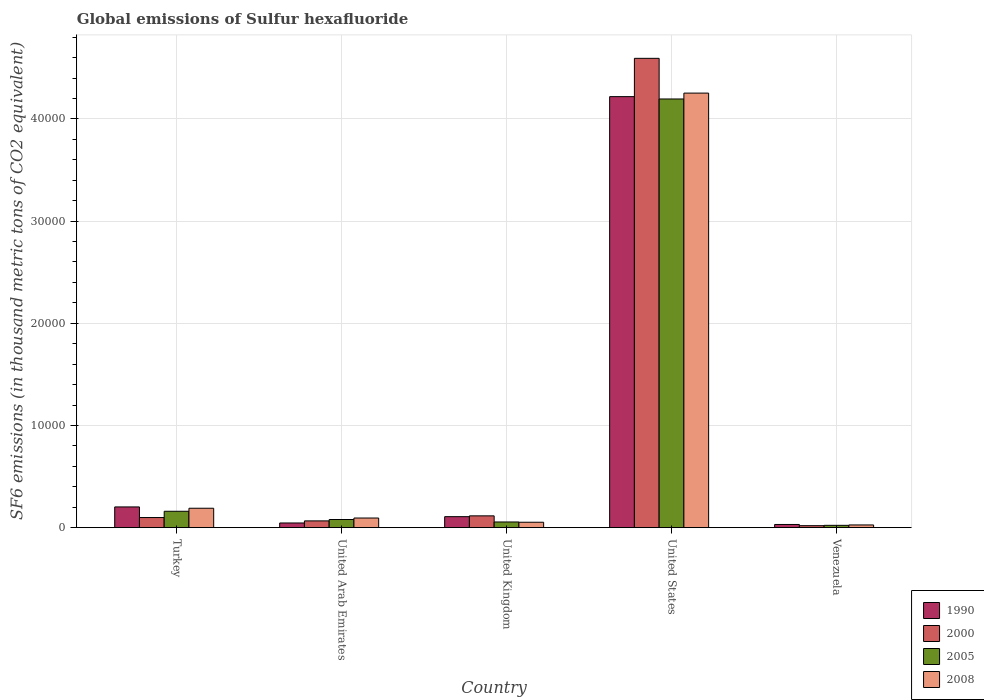How many groups of bars are there?
Provide a succinct answer. 5. Are the number of bars per tick equal to the number of legend labels?
Ensure brevity in your answer.  Yes. Are the number of bars on each tick of the X-axis equal?
Offer a terse response. Yes. How many bars are there on the 2nd tick from the left?
Your answer should be very brief. 4. How many bars are there on the 3rd tick from the right?
Give a very brief answer. 4. In how many cases, is the number of bars for a given country not equal to the number of legend labels?
Your answer should be compact. 0. What is the global emissions of Sulfur hexafluoride in 2000 in Turkey?
Ensure brevity in your answer.  989.2. Across all countries, what is the maximum global emissions of Sulfur hexafluoride in 1990?
Keep it short and to the point. 4.22e+04. Across all countries, what is the minimum global emissions of Sulfur hexafluoride in 1990?
Keep it short and to the point. 309.8. In which country was the global emissions of Sulfur hexafluoride in 2000 minimum?
Your answer should be very brief. Venezuela. What is the total global emissions of Sulfur hexafluoride in 2008 in the graph?
Ensure brevity in your answer.  4.62e+04. What is the difference between the global emissions of Sulfur hexafluoride in 2008 in United Kingdom and that in Venezuela?
Make the answer very short. 265.5. What is the difference between the global emissions of Sulfur hexafluoride in 1990 in United States and the global emissions of Sulfur hexafluoride in 2008 in Venezuela?
Offer a terse response. 4.19e+04. What is the average global emissions of Sulfur hexafluoride in 2005 per country?
Ensure brevity in your answer.  9026.12. What is the difference between the global emissions of Sulfur hexafluoride of/in 2005 and global emissions of Sulfur hexafluoride of/in 2000 in Turkey?
Provide a short and direct response. 613. What is the ratio of the global emissions of Sulfur hexafluoride in 1990 in Turkey to that in United Arab Emirates?
Keep it short and to the point. 4.44. Is the global emissions of Sulfur hexafluoride in 2005 in Turkey less than that in United Kingdom?
Offer a terse response. No. Is the difference between the global emissions of Sulfur hexafluoride in 2005 in Turkey and United Kingdom greater than the difference between the global emissions of Sulfur hexafluoride in 2000 in Turkey and United Kingdom?
Make the answer very short. Yes. What is the difference between the highest and the second highest global emissions of Sulfur hexafluoride in 1990?
Offer a very short reply. -953.2. What is the difference between the highest and the lowest global emissions of Sulfur hexafluoride in 2005?
Give a very brief answer. 4.17e+04. In how many countries, is the global emissions of Sulfur hexafluoride in 2005 greater than the average global emissions of Sulfur hexafluoride in 2005 taken over all countries?
Your answer should be very brief. 1. Is the sum of the global emissions of Sulfur hexafluoride in 2000 in United Arab Emirates and United Kingdom greater than the maximum global emissions of Sulfur hexafluoride in 2008 across all countries?
Your response must be concise. No. Is it the case that in every country, the sum of the global emissions of Sulfur hexafluoride in 1990 and global emissions of Sulfur hexafluoride in 2000 is greater than the sum of global emissions of Sulfur hexafluoride in 2005 and global emissions of Sulfur hexafluoride in 2008?
Offer a very short reply. No. What does the 4th bar from the left in Turkey represents?
Make the answer very short. 2008. What does the 2nd bar from the right in Turkey represents?
Make the answer very short. 2005. How many bars are there?
Give a very brief answer. 20. How many countries are there in the graph?
Your answer should be very brief. 5. Does the graph contain any zero values?
Make the answer very short. No. Does the graph contain grids?
Your answer should be compact. Yes. Where does the legend appear in the graph?
Make the answer very short. Bottom right. What is the title of the graph?
Your answer should be compact. Global emissions of Sulfur hexafluoride. What is the label or title of the Y-axis?
Offer a terse response. SF6 emissions (in thousand metric tons of CO2 equivalent). What is the SF6 emissions (in thousand metric tons of CO2 equivalent) of 1990 in Turkey?
Offer a very short reply. 2027.1. What is the SF6 emissions (in thousand metric tons of CO2 equivalent) in 2000 in Turkey?
Your answer should be compact. 989.2. What is the SF6 emissions (in thousand metric tons of CO2 equivalent) of 2005 in Turkey?
Offer a terse response. 1602.2. What is the SF6 emissions (in thousand metric tons of CO2 equivalent) in 2008 in Turkey?
Your answer should be very brief. 1898.8. What is the SF6 emissions (in thousand metric tons of CO2 equivalent) of 1990 in United Arab Emirates?
Provide a short and direct response. 456.1. What is the SF6 emissions (in thousand metric tons of CO2 equivalent) in 2000 in United Arab Emirates?
Make the answer very short. 660.1. What is the SF6 emissions (in thousand metric tons of CO2 equivalent) in 2005 in United Arab Emirates?
Ensure brevity in your answer.  796.2. What is the SF6 emissions (in thousand metric tons of CO2 equivalent) of 2008 in United Arab Emirates?
Make the answer very short. 941.4. What is the SF6 emissions (in thousand metric tons of CO2 equivalent) in 1990 in United Kingdom?
Your response must be concise. 1073.9. What is the SF6 emissions (in thousand metric tons of CO2 equivalent) of 2000 in United Kingdom?
Give a very brief answer. 1154.1. What is the SF6 emissions (in thousand metric tons of CO2 equivalent) in 2005 in United Kingdom?
Provide a succinct answer. 554.2. What is the SF6 emissions (in thousand metric tons of CO2 equivalent) of 2008 in United Kingdom?
Provide a short and direct response. 528.9. What is the SF6 emissions (in thousand metric tons of CO2 equivalent) in 1990 in United States?
Your answer should be very brief. 4.22e+04. What is the SF6 emissions (in thousand metric tons of CO2 equivalent) in 2000 in United States?
Offer a very short reply. 4.59e+04. What is the SF6 emissions (in thousand metric tons of CO2 equivalent) in 2005 in United States?
Your answer should be very brief. 4.20e+04. What is the SF6 emissions (in thousand metric tons of CO2 equivalent) of 2008 in United States?
Provide a succinct answer. 4.25e+04. What is the SF6 emissions (in thousand metric tons of CO2 equivalent) in 1990 in Venezuela?
Offer a terse response. 309.8. What is the SF6 emissions (in thousand metric tons of CO2 equivalent) of 2000 in Venezuela?
Offer a very short reply. 191.4. What is the SF6 emissions (in thousand metric tons of CO2 equivalent) of 2005 in Venezuela?
Give a very brief answer. 225.1. What is the SF6 emissions (in thousand metric tons of CO2 equivalent) in 2008 in Venezuela?
Provide a succinct answer. 263.4. Across all countries, what is the maximum SF6 emissions (in thousand metric tons of CO2 equivalent) of 1990?
Your response must be concise. 4.22e+04. Across all countries, what is the maximum SF6 emissions (in thousand metric tons of CO2 equivalent) of 2000?
Your answer should be very brief. 4.59e+04. Across all countries, what is the maximum SF6 emissions (in thousand metric tons of CO2 equivalent) of 2005?
Give a very brief answer. 4.20e+04. Across all countries, what is the maximum SF6 emissions (in thousand metric tons of CO2 equivalent) of 2008?
Provide a succinct answer. 4.25e+04. Across all countries, what is the minimum SF6 emissions (in thousand metric tons of CO2 equivalent) in 1990?
Offer a terse response. 309.8. Across all countries, what is the minimum SF6 emissions (in thousand metric tons of CO2 equivalent) in 2000?
Give a very brief answer. 191.4. Across all countries, what is the minimum SF6 emissions (in thousand metric tons of CO2 equivalent) of 2005?
Keep it short and to the point. 225.1. Across all countries, what is the minimum SF6 emissions (in thousand metric tons of CO2 equivalent) of 2008?
Your answer should be very brief. 263.4. What is the total SF6 emissions (in thousand metric tons of CO2 equivalent) of 1990 in the graph?
Keep it short and to the point. 4.60e+04. What is the total SF6 emissions (in thousand metric tons of CO2 equivalent) of 2000 in the graph?
Give a very brief answer. 4.89e+04. What is the total SF6 emissions (in thousand metric tons of CO2 equivalent) of 2005 in the graph?
Give a very brief answer. 4.51e+04. What is the total SF6 emissions (in thousand metric tons of CO2 equivalent) in 2008 in the graph?
Your answer should be very brief. 4.62e+04. What is the difference between the SF6 emissions (in thousand metric tons of CO2 equivalent) of 1990 in Turkey and that in United Arab Emirates?
Keep it short and to the point. 1571. What is the difference between the SF6 emissions (in thousand metric tons of CO2 equivalent) of 2000 in Turkey and that in United Arab Emirates?
Your response must be concise. 329.1. What is the difference between the SF6 emissions (in thousand metric tons of CO2 equivalent) of 2005 in Turkey and that in United Arab Emirates?
Ensure brevity in your answer.  806. What is the difference between the SF6 emissions (in thousand metric tons of CO2 equivalent) in 2008 in Turkey and that in United Arab Emirates?
Provide a succinct answer. 957.4. What is the difference between the SF6 emissions (in thousand metric tons of CO2 equivalent) in 1990 in Turkey and that in United Kingdom?
Make the answer very short. 953.2. What is the difference between the SF6 emissions (in thousand metric tons of CO2 equivalent) in 2000 in Turkey and that in United Kingdom?
Give a very brief answer. -164.9. What is the difference between the SF6 emissions (in thousand metric tons of CO2 equivalent) in 2005 in Turkey and that in United Kingdom?
Your response must be concise. 1048. What is the difference between the SF6 emissions (in thousand metric tons of CO2 equivalent) in 2008 in Turkey and that in United Kingdom?
Offer a very short reply. 1369.9. What is the difference between the SF6 emissions (in thousand metric tons of CO2 equivalent) of 1990 in Turkey and that in United States?
Offer a very short reply. -4.02e+04. What is the difference between the SF6 emissions (in thousand metric tons of CO2 equivalent) of 2000 in Turkey and that in United States?
Ensure brevity in your answer.  -4.49e+04. What is the difference between the SF6 emissions (in thousand metric tons of CO2 equivalent) in 2005 in Turkey and that in United States?
Ensure brevity in your answer.  -4.04e+04. What is the difference between the SF6 emissions (in thousand metric tons of CO2 equivalent) of 2008 in Turkey and that in United States?
Ensure brevity in your answer.  -4.06e+04. What is the difference between the SF6 emissions (in thousand metric tons of CO2 equivalent) of 1990 in Turkey and that in Venezuela?
Offer a very short reply. 1717.3. What is the difference between the SF6 emissions (in thousand metric tons of CO2 equivalent) in 2000 in Turkey and that in Venezuela?
Ensure brevity in your answer.  797.8. What is the difference between the SF6 emissions (in thousand metric tons of CO2 equivalent) in 2005 in Turkey and that in Venezuela?
Offer a terse response. 1377.1. What is the difference between the SF6 emissions (in thousand metric tons of CO2 equivalent) in 2008 in Turkey and that in Venezuela?
Provide a short and direct response. 1635.4. What is the difference between the SF6 emissions (in thousand metric tons of CO2 equivalent) in 1990 in United Arab Emirates and that in United Kingdom?
Offer a terse response. -617.8. What is the difference between the SF6 emissions (in thousand metric tons of CO2 equivalent) of 2000 in United Arab Emirates and that in United Kingdom?
Your response must be concise. -494. What is the difference between the SF6 emissions (in thousand metric tons of CO2 equivalent) of 2005 in United Arab Emirates and that in United Kingdom?
Offer a terse response. 242. What is the difference between the SF6 emissions (in thousand metric tons of CO2 equivalent) of 2008 in United Arab Emirates and that in United Kingdom?
Provide a succinct answer. 412.5. What is the difference between the SF6 emissions (in thousand metric tons of CO2 equivalent) of 1990 in United Arab Emirates and that in United States?
Your answer should be compact. -4.17e+04. What is the difference between the SF6 emissions (in thousand metric tons of CO2 equivalent) in 2000 in United Arab Emirates and that in United States?
Give a very brief answer. -4.53e+04. What is the difference between the SF6 emissions (in thousand metric tons of CO2 equivalent) in 2005 in United Arab Emirates and that in United States?
Offer a very short reply. -4.12e+04. What is the difference between the SF6 emissions (in thousand metric tons of CO2 equivalent) in 2008 in United Arab Emirates and that in United States?
Provide a short and direct response. -4.16e+04. What is the difference between the SF6 emissions (in thousand metric tons of CO2 equivalent) of 1990 in United Arab Emirates and that in Venezuela?
Give a very brief answer. 146.3. What is the difference between the SF6 emissions (in thousand metric tons of CO2 equivalent) of 2000 in United Arab Emirates and that in Venezuela?
Provide a short and direct response. 468.7. What is the difference between the SF6 emissions (in thousand metric tons of CO2 equivalent) in 2005 in United Arab Emirates and that in Venezuela?
Offer a very short reply. 571.1. What is the difference between the SF6 emissions (in thousand metric tons of CO2 equivalent) in 2008 in United Arab Emirates and that in Venezuela?
Your answer should be very brief. 678. What is the difference between the SF6 emissions (in thousand metric tons of CO2 equivalent) in 1990 in United Kingdom and that in United States?
Offer a terse response. -4.11e+04. What is the difference between the SF6 emissions (in thousand metric tons of CO2 equivalent) in 2000 in United Kingdom and that in United States?
Your answer should be compact. -4.48e+04. What is the difference between the SF6 emissions (in thousand metric tons of CO2 equivalent) in 2005 in United Kingdom and that in United States?
Provide a succinct answer. -4.14e+04. What is the difference between the SF6 emissions (in thousand metric tons of CO2 equivalent) of 2008 in United Kingdom and that in United States?
Your answer should be compact. -4.20e+04. What is the difference between the SF6 emissions (in thousand metric tons of CO2 equivalent) in 1990 in United Kingdom and that in Venezuela?
Provide a short and direct response. 764.1. What is the difference between the SF6 emissions (in thousand metric tons of CO2 equivalent) of 2000 in United Kingdom and that in Venezuela?
Your answer should be compact. 962.7. What is the difference between the SF6 emissions (in thousand metric tons of CO2 equivalent) of 2005 in United Kingdom and that in Venezuela?
Keep it short and to the point. 329.1. What is the difference between the SF6 emissions (in thousand metric tons of CO2 equivalent) of 2008 in United Kingdom and that in Venezuela?
Ensure brevity in your answer.  265.5. What is the difference between the SF6 emissions (in thousand metric tons of CO2 equivalent) in 1990 in United States and that in Venezuela?
Provide a succinct answer. 4.19e+04. What is the difference between the SF6 emissions (in thousand metric tons of CO2 equivalent) of 2000 in United States and that in Venezuela?
Keep it short and to the point. 4.57e+04. What is the difference between the SF6 emissions (in thousand metric tons of CO2 equivalent) in 2005 in United States and that in Venezuela?
Your response must be concise. 4.17e+04. What is the difference between the SF6 emissions (in thousand metric tons of CO2 equivalent) of 2008 in United States and that in Venezuela?
Keep it short and to the point. 4.23e+04. What is the difference between the SF6 emissions (in thousand metric tons of CO2 equivalent) in 1990 in Turkey and the SF6 emissions (in thousand metric tons of CO2 equivalent) in 2000 in United Arab Emirates?
Your answer should be very brief. 1367. What is the difference between the SF6 emissions (in thousand metric tons of CO2 equivalent) in 1990 in Turkey and the SF6 emissions (in thousand metric tons of CO2 equivalent) in 2005 in United Arab Emirates?
Offer a terse response. 1230.9. What is the difference between the SF6 emissions (in thousand metric tons of CO2 equivalent) of 1990 in Turkey and the SF6 emissions (in thousand metric tons of CO2 equivalent) of 2008 in United Arab Emirates?
Offer a terse response. 1085.7. What is the difference between the SF6 emissions (in thousand metric tons of CO2 equivalent) of 2000 in Turkey and the SF6 emissions (in thousand metric tons of CO2 equivalent) of 2005 in United Arab Emirates?
Keep it short and to the point. 193. What is the difference between the SF6 emissions (in thousand metric tons of CO2 equivalent) in 2000 in Turkey and the SF6 emissions (in thousand metric tons of CO2 equivalent) in 2008 in United Arab Emirates?
Keep it short and to the point. 47.8. What is the difference between the SF6 emissions (in thousand metric tons of CO2 equivalent) of 2005 in Turkey and the SF6 emissions (in thousand metric tons of CO2 equivalent) of 2008 in United Arab Emirates?
Your answer should be compact. 660.8. What is the difference between the SF6 emissions (in thousand metric tons of CO2 equivalent) of 1990 in Turkey and the SF6 emissions (in thousand metric tons of CO2 equivalent) of 2000 in United Kingdom?
Your response must be concise. 873. What is the difference between the SF6 emissions (in thousand metric tons of CO2 equivalent) in 1990 in Turkey and the SF6 emissions (in thousand metric tons of CO2 equivalent) in 2005 in United Kingdom?
Provide a short and direct response. 1472.9. What is the difference between the SF6 emissions (in thousand metric tons of CO2 equivalent) in 1990 in Turkey and the SF6 emissions (in thousand metric tons of CO2 equivalent) in 2008 in United Kingdom?
Make the answer very short. 1498.2. What is the difference between the SF6 emissions (in thousand metric tons of CO2 equivalent) in 2000 in Turkey and the SF6 emissions (in thousand metric tons of CO2 equivalent) in 2005 in United Kingdom?
Provide a short and direct response. 435. What is the difference between the SF6 emissions (in thousand metric tons of CO2 equivalent) in 2000 in Turkey and the SF6 emissions (in thousand metric tons of CO2 equivalent) in 2008 in United Kingdom?
Your answer should be compact. 460.3. What is the difference between the SF6 emissions (in thousand metric tons of CO2 equivalent) of 2005 in Turkey and the SF6 emissions (in thousand metric tons of CO2 equivalent) of 2008 in United Kingdom?
Your answer should be very brief. 1073.3. What is the difference between the SF6 emissions (in thousand metric tons of CO2 equivalent) of 1990 in Turkey and the SF6 emissions (in thousand metric tons of CO2 equivalent) of 2000 in United States?
Your answer should be compact. -4.39e+04. What is the difference between the SF6 emissions (in thousand metric tons of CO2 equivalent) of 1990 in Turkey and the SF6 emissions (in thousand metric tons of CO2 equivalent) of 2005 in United States?
Offer a terse response. -3.99e+04. What is the difference between the SF6 emissions (in thousand metric tons of CO2 equivalent) of 1990 in Turkey and the SF6 emissions (in thousand metric tons of CO2 equivalent) of 2008 in United States?
Keep it short and to the point. -4.05e+04. What is the difference between the SF6 emissions (in thousand metric tons of CO2 equivalent) of 2000 in Turkey and the SF6 emissions (in thousand metric tons of CO2 equivalent) of 2005 in United States?
Your answer should be very brief. -4.10e+04. What is the difference between the SF6 emissions (in thousand metric tons of CO2 equivalent) in 2000 in Turkey and the SF6 emissions (in thousand metric tons of CO2 equivalent) in 2008 in United States?
Ensure brevity in your answer.  -4.15e+04. What is the difference between the SF6 emissions (in thousand metric tons of CO2 equivalent) in 2005 in Turkey and the SF6 emissions (in thousand metric tons of CO2 equivalent) in 2008 in United States?
Offer a terse response. -4.09e+04. What is the difference between the SF6 emissions (in thousand metric tons of CO2 equivalent) of 1990 in Turkey and the SF6 emissions (in thousand metric tons of CO2 equivalent) of 2000 in Venezuela?
Your answer should be very brief. 1835.7. What is the difference between the SF6 emissions (in thousand metric tons of CO2 equivalent) of 1990 in Turkey and the SF6 emissions (in thousand metric tons of CO2 equivalent) of 2005 in Venezuela?
Provide a short and direct response. 1802. What is the difference between the SF6 emissions (in thousand metric tons of CO2 equivalent) in 1990 in Turkey and the SF6 emissions (in thousand metric tons of CO2 equivalent) in 2008 in Venezuela?
Ensure brevity in your answer.  1763.7. What is the difference between the SF6 emissions (in thousand metric tons of CO2 equivalent) in 2000 in Turkey and the SF6 emissions (in thousand metric tons of CO2 equivalent) in 2005 in Venezuela?
Provide a succinct answer. 764.1. What is the difference between the SF6 emissions (in thousand metric tons of CO2 equivalent) in 2000 in Turkey and the SF6 emissions (in thousand metric tons of CO2 equivalent) in 2008 in Venezuela?
Provide a succinct answer. 725.8. What is the difference between the SF6 emissions (in thousand metric tons of CO2 equivalent) of 2005 in Turkey and the SF6 emissions (in thousand metric tons of CO2 equivalent) of 2008 in Venezuela?
Offer a very short reply. 1338.8. What is the difference between the SF6 emissions (in thousand metric tons of CO2 equivalent) in 1990 in United Arab Emirates and the SF6 emissions (in thousand metric tons of CO2 equivalent) in 2000 in United Kingdom?
Make the answer very short. -698. What is the difference between the SF6 emissions (in thousand metric tons of CO2 equivalent) of 1990 in United Arab Emirates and the SF6 emissions (in thousand metric tons of CO2 equivalent) of 2005 in United Kingdom?
Give a very brief answer. -98.1. What is the difference between the SF6 emissions (in thousand metric tons of CO2 equivalent) of 1990 in United Arab Emirates and the SF6 emissions (in thousand metric tons of CO2 equivalent) of 2008 in United Kingdom?
Make the answer very short. -72.8. What is the difference between the SF6 emissions (in thousand metric tons of CO2 equivalent) of 2000 in United Arab Emirates and the SF6 emissions (in thousand metric tons of CO2 equivalent) of 2005 in United Kingdom?
Keep it short and to the point. 105.9. What is the difference between the SF6 emissions (in thousand metric tons of CO2 equivalent) of 2000 in United Arab Emirates and the SF6 emissions (in thousand metric tons of CO2 equivalent) of 2008 in United Kingdom?
Provide a succinct answer. 131.2. What is the difference between the SF6 emissions (in thousand metric tons of CO2 equivalent) of 2005 in United Arab Emirates and the SF6 emissions (in thousand metric tons of CO2 equivalent) of 2008 in United Kingdom?
Your answer should be very brief. 267.3. What is the difference between the SF6 emissions (in thousand metric tons of CO2 equivalent) of 1990 in United Arab Emirates and the SF6 emissions (in thousand metric tons of CO2 equivalent) of 2000 in United States?
Your answer should be compact. -4.55e+04. What is the difference between the SF6 emissions (in thousand metric tons of CO2 equivalent) of 1990 in United Arab Emirates and the SF6 emissions (in thousand metric tons of CO2 equivalent) of 2005 in United States?
Give a very brief answer. -4.15e+04. What is the difference between the SF6 emissions (in thousand metric tons of CO2 equivalent) of 1990 in United Arab Emirates and the SF6 emissions (in thousand metric tons of CO2 equivalent) of 2008 in United States?
Your answer should be compact. -4.21e+04. What is the difference between the SF6 emissions (in thousand metric tons of CO2 equivalent) in 2000 in United Arab Emirates and the SF6 emissions (in thousand metric tons of CO2 equivalent) in 2005 in United States?
Ensure brevity in your answer.  -4.13e+04. What is the difference between the SF6 emissions (in thousand metric tons of CO2 equivalent) in 2000 in United Arab Emirates and the SF6 emissions (in thousand metric tons of CO2 equivalent) in 2008 in United States?
Give a very brief answer. -4.19e+04. What is the difference between the SF6 emissions (in thousand metric tons of CO2 equivalent) in 2005 in United Arab Emirates and the SF6 emissions (in thousand metric tons of CO2 equivalent) in 2008 in United States?
Keep it short and to the point. -4.17e+04. What is the difference between the SF6 emissions (in thousand metric tons of CO2 equivalent) in 1990 in United Arab Emirates and the SF6 emissions (in thousand metric tons of CO2 equivalent) in 2000 in Venezuela?
Make the answer very short. 264.7. What is the difference between the SF6 emissions (in thousand metric tons of CO2 equivalent) in 1990 in United Arab Emirates and the SF6 emissions (in thousand metric tons of CO2 equivalent) in 2005 in Venezuela?
Offer a terse response. 231. What is the difference between the SF6 emissions (in thousand metric tons of CO2 equivalent) in 1990 in United Arab Emirates and the SF6 emissions (in thousand metric tons of CO2 equivalent) in 2008 in Venezuela?
Give a very brief answer. 192.7. What is the difference between the SF6 emissions (in thousand metric tons of CO2 equivalent) of 2000 in United Arab Emirates and the SF6 emissions (in thousand metric tons of CO2 equivalent) of 2005 in Venezuela?
Your answer should be compact. 435. What is the difference between the SF6 emissions (in thousand metric tons of CO2 equivalent) in 2000 in United Arab Emirates and the SF6 emissions (in thousand metric tons of CO2 equivalent) in 2008 in Venezuela?
Your response must be concise. 396.7. What is the difference between the SF6 emissions (in thousand metric tons of CO2 equivalent) in 2005 in United Arab Emirates and the SF6 emissions (in thousand metric tons of CO2 equivalent) in 2008 in Venezuela?
Your answer should be compact. 532.8. What is the difference between the SF6 emissions (in thousand metric tons of CO2 equivalent) in 1990 in United Kingdom and the SF6 emissions (in thousand metric tons of CO2 equivalent) in 2000 in United States?
Keep it short and to the point. -4.49e+04. What is the difference between the SF6 emissions (in thousand metric tons of CO2 equivalent) in 1990 in United Kingdom and the SF6 emissions (in thousand metric tons of CO2 equivalent) in 2005 in United States?
Offer a terse response. -4.09e+04. What is the difference between the SF6 emissions (in thousand metric tons of CO2 equivalent) of 1990 in United Kingdom and the SF6 emissions (in thousand metric tons of CO2 equivalent) of 2008 in United States?
Give a very brief answer. -4.15e+04. What is the difference between the SF6 emissions (in thousand metric tons of CO2 equivalent) of 2000 in United Kingdom and the SF6 emissions (in thousand metric tons of CO2 equivalent) of 2005 in United States?
Make the answer very short. -4.08e+04. What is the difference between the SF6 emissions (in thousand metric tons of CO2 equivalent) of 2000 in United Kingdom and the SF6 emissions (in thousand metric tons of CO2 equivalent) of 2008 in United States?
Make the answer very short. -4.14e+04. What is the difference between the SF6 emissions (in thousand metric tons of CO2 equivalent) of 2005 in United Kingdom and the SF6 emissions (in thousand metric tons of CO2 equivalent) of 2008 in United States?
Keep it short and to the point. -4.20e+04. What is the difference between the SF6 emissions (in thousand metric tons of CO2 equivalent) of 1990 in United Kingdom and the SF6 emissions (in thousand metric tons of CO2 equivalent) of 2000 in Venezuela?
Make the answer very short. 882.5. What is the difference between the SF6 emissions (in thousand metric tons of CO2 equivalent) in 1990 in United Kingdom and the SF6 emissions (in thousand metric tons of CO2 equivalent) in 2005 in Venezuela?
Ensure brevity in your answer.  848.8. What is the difference between the SF6 emissions (in thousand metric tons of CO2 equivalent) of 1990 in United Kingdom and the SF6 emissions (in thousand metric tons of CO2 equivalent) of 2008 in Venezuela?
Offer a terse response. 810.5. What is the difference between the SF6 emissions (in thousand metric tons of CO2 equivalent) of 2000 in United Kingdom and the SF6 emissions (in thousand metric tons of CO2 equivalent) of 2005 in Venezuela?
Offer a very short reply. 929. What is the difference between the SF6 emissions (in thousand metric tons of CO2 equivalent) of 2000 in United Kingdom and the SF6 emissions (in thousand metric tons of CO2 equivalent) of 2008 in Venezuela?
Your answer should be very brief. 890.7. What is the difference between the SF6 emissions (in thousand metric tons of CO2 equivalent) in 2005 in United Kingdom and the SF6 emissions (in thousand metric tons of CO2 equivalent) in 2008 in Venezuela?
Your answer should be very brief. 290.8. What is the difference between the SF6 emissions (in thousand metric tons of CO2 equivalent) in 1990 in United States and the SF6 emissions (in thousand metric tons of CO2 equivalent) in 2000 in Venezuela?
Ensure brevity in your answer.  4.20e+04. What is the difference between the SF6 emissions (in thousand metric tons of CO2 equivalent) of 1990 in United States and the SF6 emissions (in thousand metric tons of CO2 equivalent) of 2005 in Venezuela?
Keep it short and to the point. 4.20e+04. What is the difference between the SF6 emissions (in thousand metric tons of CO2 equivalent) of 1990 in United States and the SF6 emissions (in thousand metric tons of CO2 equivalent) of 2008 in Venezuela?
Give a very brief answer. 4.19e+04. What is the difference between the SF6 emissions (in thousand metric tons of CO2 equivalent) in 2000 in United States and the SF6 emissions (in thousand metric tons of CO2 equivalent) in 2005 in Venezuela?
Make the answer very short. 4.57e+04. What is the difference between the SF6 emissions (in thousand metric tons of CO2 equivalent) of 2000 in United States and the SF6 emissions (in thousand metric tons of CO2 equivalent) of 2008 in Venezuela?
Give a very brief answer. 4.57e+04. What is the difference between the SF6 emissions (in thousand metric tons of CO2 equivalent) in 2005 in United States and the SF6 emissions (in thousand metric tons of CO2 equivalent) in 2008 in Venezuela?
Your response must be concise. 4.17e+04. What is the average SF6 emissions (in thousand metric tons of CO2 equivalent) in 1990 per country?
Keep it short and to the point. 9209.88. What is the average SF6 emissions (in thousand metric tons of CO2 equivalent) of 2000 per country?
Offer a very short reply. 9784.98. What is the average SF6 emissions (in thousand metric tons of CO2 equivalent) of 2005 per country?
Your answer should be compact. 9026.12. What is the average SF6 emissions (in thousand metric tons of CO2 equivalent) of 2008 per country?
Keep it short and to the point. 9232.22. What is the difference between the SF6 emissions (in thousand metric tons of CO2 equivalent) of 1990 and SF6 emissions (in thousand metric tons of CO2 equivalent) of 2000 in Turkey?
Ensure brevity in your answer.  1037.9. What is the difference between the SF6 emissions (in thousand metric tons of CO2 equivalent) in 1990 and SF6 emissions (in thousand metric tons of CO2 equivalent) in 2005 in Turkey?
Offer a very short reply. 424.9. What is the difference between the SF6 emissions (in thousand metric tons of CO2 equivalent) of 1990 and SF6 emissions (in thousand metric tons of CO2 equivalent) of 2008 in Turkey?
Ensure brevity in your answer.  128.3. What is the difference between the SF6 emissions (in thousand metric tons of CO2 equivalent) in 2000 and SF6 emissions (in thousand metric tons of CO2 equivalent) in 2005 in Turkey?
Provide a succinct answer. -613. What is the difference between the SF6 emissions (in thousand metric tons of CO2 equivalent) of 2000 and SF6 emissions (in thousand metric tons of CO2 equivalent) of 2008 in Turkey?
Offer a terse response. -909.6. What is the difference between the SF6 emissions (in thousand metric tons of CO2 equivalent) in 2005 and SF6 emissions (in thousand metric tons of CO2 equivalent) in 2008 in Turkey?
Ensure brevity in your answer.  -296.6. What is the difference between the SF6 emissions (in thousand metric tons of CO2 equivalent) of 1990 and SF6 emissions (in thousand metric tons of CO2 equivalent) of 2000 in United Arab Emirates?
Make the answer very short. -204. What is the difference between the SF6 emissions (in thousand metric tons of CO2 equivalent) in 1990 and SF6 emissions (in thousand metric tons of CO2 equivalent) in 2005 in United Arab Emirates?
Give a very brief answer. -340.1. What is the difference between the SF6 emissions (in thousand metric tons of CO2 equivalent) in 1990 and SF6 emissions (in thousand metric tons of CO2 equivalent) in 2008 in United Arab Emirates?
Ensure brevity in your answer.  -485.3. What is the difference between the SF6 emissions (in thousand metric tons of CO2 equivalent) in 2000 and SF6 emissions (in thousand metric tons of CO2 equivalent) in 2005 in United Arab Emirates?
Provide a short and direct response. -136.1. What is the difference between the SF6 emissions (in thousand metric tons of CO2 equivalent) in 2000 and SF6 emissions (in thousand metric tons of CO2 equivalent) in 2008 in United Arab Emirates?
Ensure brevity in your answer.  -281.3. What is the difference between the SF6 emissions (in thousand metric tons of CO2 equivalent) in 2005 and SF6 emissions (in thousand metric tons of CO2 equivalent) in 2008 in United Arab Emirates?
Give a very brief answer. -145.2. What is the difference between the SF6 emissions (in thousand metric tons of CO2 equivalent) in 1990 and SF6 emissions (in thousand metric tons of CO2 equivalent) in 2000 in United Kingdom?
Your response must be concise. -80.2. What is the difference between the SF6 emissions (in thousand metric tons of CO2 equivalent) in 1990 and SF6 emissions (in thousand metric tons of CO2 equivalent) in 2005 in United Kingdom?
Offer a very short reply. 519.7. What is the difference between the SF6 emissions (in thousand metric tons of CO2 equivalent) in 1990 and SF6 emissions (in thousand metric tons of CO2 equivalent) in 2008 in United Kingdom?
Ensure brevity in your answer.  545. What is the difference between the SF6 emissions (in thousand metric tons of CO2 equivalent) of 2000 and SF6 emissions (in thousand metric tons of CO2 equivalent) of 2005 in United Kingdom?
Your answer should be compact. 599.9. What is the difference between the SF6 emissions (in thousand metric tons of CO2 equivalent) in 2000 and SF6 emissions (in thousand metric tons of CO2 equivalent) in 2008 in United Kingdom?
Make the answer very short. 625.2. What is the difference between the SF6 emissions (in thousand metric tons of CO2 equivalent) in 2005 and SF6 emissions (in thousand metric tons of CO2 equivalent) in 2008 in United Kingdom?
Your response must be concise. 25.3. What is the difference between the SF6 emissions (in thousand metric tons of CO2 equivalent) of 1990 and SF6 emissions (in thousand metric tons of CO2 equivalent) of 2000 in United States?
Offer a terse response. -3747.6. What is the difference between the SF6 emissions (in thousand metric tons of CO2 equivalent) of 1990 and SF6 emissions (in thousand metric tons of CO2 equivalent) of 2005 in United States?
Your answer should be very brief. 229.6. What is the difference between the SF6 emissions (in thousand metric tons of CO2 equivalent) in 1990 and SF6 emissions (in thousand metric tons of CO2 equivalent) in 2008 in United States?
Make the answer very short. -346.1. What is the difference between the SF6 emissions (in thousand metric tons of CO2 equivalent) of 2000 and SF6 emissions (in thousand metric tons of CO2 equivalent) of 2005 in United States?
Offer a terse response. 3977.2. What is the difference between the SF6 emissions (in thousand metric tons of CO2 equivalent) in 2000 and SF6 emissions (in thousand metric tons of CO2 equivalent) in 2008 in United States?
Keep it short and to the point. 3401.5. What is the difference between the SF6 emissions (in thousand metric tons of CO2 equivalent) of 2005 and SF6 emissions (in thousand metric tons of CO2 equivalent) of 2008 in United States?
Your response must be concise. -575.7. What is the difference between the SF6 emissions (in thousand metric tons of CO2 equivalent) in 1990 and SF6 emissions (in thousand metric tons of CO2 equivalent) in 2000 in Venezuela?
Your answer should be very brief. 118.4. What is the difference between the SF6 emissions (in thousand metric tons of CO2 equivalent) in 1990 and SF6 emissions (in thousand metric tons of CO2 equivalent) in 2005 in Venezuela?
Keep it short and to the point. 84.7. What is the difference between the SF6 emissions (in thousand metric tons of CO2 equivalent) in 1990 and SF6 emissions (in thousand metric tons of CO2 equivalent) in 2008 in Venezuela?
Your response must be concise. 46.4. What is the difference between the SF6 emissions (in thousand metric tons of CO2 equivalent) in 2000 and SF6 emissions (in thousand metric tons of CO2 equivalent) in 2005 in Venezuela?
Ensure brevity in your answer.  -33.7. What is the difference between the SF6 emissions (in thousand metric tons of CO2 equivalent) of 2000 and SF6 emissions (in thousand metric tons of CO2 equivalent) of 2008 in Venezuela?
Give a very brief answer. -72. What is the difference between the SF6 emissions (in thousand metric tons of CO2 equivalent) in 2005 and SF6 emissions (in thousand metric tons of CO2 equivalent) in 2008 in Venezuela?
Your answer should be compact. -38.3. What is the ratio of the SF6 emissions (in thousand metric tons of CO2 equivalent) in 1990 in Turkey to that in United Arab Emirates?
Your response must be concise. 4.44. What is the ratio of the SF6 emissions (in thousand metric tons of CO2 equivalent) in 2000 in Turkey to that in United Arab Emirates?
Provide a succinct answer. 1.5. What is the ratio of the SF6 emissions (in thousand metric tons of CO2 equivalent) in 2005 in Turkey to that in United Arab Emirates?
Offer a very short reply. 2.01. What is the ratio of the SF6 emissions (in thousand metric tons of CO2 equivalent) in 2008 in Turkey to that in United Arab Emirates?
Provide a succinct answer. 2.02. What is the ratio of the SF6 emissions (in thousand metric tons of CO2 equivalent) of 1990 in Turkey to that in United Kingdom?
Keep it short and to the point. 1.89. What is the ratio of the SF6 emissions (in thousand metric tons of CO2 equivalent) of 2000 in Turkey to that in United Kingdom?
Offer a very short reply. 0.86. What is the ratio of the SF6 emissions (in thousand metric tons of CO2 equivalent) of 2005 in Turkey to that in United Kingdom?
Provide a short and direct response. 2.89. What is the ratio of the SF6 emissions (in thousand metric tons of CO2 equivalent) in 2008 in Turkey to that in United Kingdom?
Make the answer very short. 3.59. What is the ratio of the SF6 emissions (in thousand metric tons of CO2 equivalent) of 1990 in Turkey to that in United States?
Your answer should be very brief. 0.05. What is the ratio of the SF6 emissions (in thousand metric tons of CO2 equivalent) in 2000 in Turkey to that in United States?
Offer a very short reply. 0.02. What is the ratio of the SF6 emissions (in thousand metric tons of CO2 equivalent) in 2005 in Turkey to that in United States?
Make the answer very short. 0.04. What is the ratio of the SF6 emissions (in thousand metric tons of CO2 equivalent) of 2008 in Turkey to that in United States?
Your answer should be compact. 0.04. What is the ratio of the SF6 emissions (in thousand metric tons of CO2 equivalent) of 1990 in Turkey to that in Venezuela?
Give a very brief answer. 6.54. What is the ratio of the SF6 emissions (in thousand metric tons of CO2 equivalent) of 2000 in Turkey to that in Venezuela?
Offer a terse response. 5.17. What is the ratio of the SF6 emissions (in thousand metric tons of CO2 equivalent) in 2005 in Turkey to that in Venezuela?
Make the answer very short. 7.12. What is the ratio of the SF6 emissions (in thousand metric tons of CO2 equivalent) of 2008 in Turkey to that in Venezuela?
Offer a terse response. 7.21. What is the ratio of the SF6 emissions (in thousand metric tons of CO2 equivalent) in 1990 in United Arab Emirates to that in United Kingdom?
Your answer should be compact. 0.42. What is the ratio of the SF6 emissions (in thousand metric tons of CO2 equivalent) of 2000 in United Arab Emirates to that in United Kingdom?
Your answer should be compact. 0.57. What is the ratio of the SF6 emissions (in thousand metric tons of CO2 equivalent) of 2005 in United Arab Emirates to that in United Kingdom?
Your answer should be very brief. 1.44. What is the ratio of the SF6 emissions (in thousand metric tons of CO2 equivalent) of 2008 in United Arab Emirates to that in United Kingdom?
Your answer should be very brief. 1.78. What is the ratio of the SF6 emissions (in thousand metric tons of CO2 equivalent) of 1990 in United Arab Emirates to that in United States?
Provide a short and direct response. 0.01. What is the ratio of the SF6 emissions (in thousand metric tons of CO2 equivalent) of 2000 in United Arab Emirates to that in United States?
Your response must be concise. 0.01. What is the ratio of the SF6 emissions (in thousand metric tons of CO2 equivalent) of 2005 in United Arab Emirates to that in United States?
Your response must be concise. 0.02. What is the ratio of the SF6 emissions (in thousand metric tons of CO2 equivalent) in 2008 in United Arab Emirates to that in United States?
Keep it short and to the point. 0.02. What is the ratio of the SF6 emissions (in thousand metric tons of CO2 equivalent) of 1990 in United Arab Emirates to that in Venezuela?
Make the answer very short. 1.47. What is the ratio of the SF6 emissions (in thousand metric tons of CO2 equivalent) of 2000 in United Arab Emirates to that in Venezuela?
Your response must be concise. 3.45. What is the ratio of the SF6 emissions (in thousand metric tons of CO2 equivalent) of 2005 in United Arab Emirates to that in Venezuela?
Keep it short and to the point. 3.54. What is the ratio of the SF6 emissions (in thousand metric tons of CO2 equivalent) of 2008 in United Arab Emirates to that in Venezuela?
Ensure brevity in your answer.  3.57. What is the ratio of the SF6 emissions (in thousand metric tons of CO2 equivalent) of 1990 in United Kingdom to that in United States?
Offer a terse response. 0.03. What is the ratio of the SF6 emissions (in thousand metric tons of CO2 equivalent) in 2000 in United Kingdom to that in United States?
Offer a terse response. 0.03. What is the ratio of the SF6 emissions (in thousand metric tons of CO2 equivalent) of 2005 in United Kingdom to that in United States?
Provide a succinct answer. 0.01. What is the ratio of the SF6 emissions (in thousand metric tons of CO2 equivalent) in 2008 in United Kingdom to that in United States?
Provide a short and direct response. 0.01. What is the ratio of the SF6 emissions (in thousand metric tons of CO2 equivalent) of 1990 in United Kingdom to that in Venezuela?
Offer a terse response. 3.47. What is the ratio of the SF6 emissions (in thousand metric tons of CO2 equivalent) of 2000 in United Kingdom to that in Venezuela?
Ensure brevity in your answer.  6.03. What is the ratio of the SF6 emissions (in thousand metric tons of CO2 equivalent) of 2005 in United Kingdom to that in Venezuela?
Ensure brevity in your answer.  2.46. What is the ratio of the SF6 emissions (in thousand metric tons of CO2 equivalent) in 2008 in United Kingdom to that in Venezuela?
Your answer should be very brief. 2.01. What is the ratio of the SF6 emissions (in thousand metric tons of CO2 equivalent) in 1990 in United States to that in Venezuela?
Keep it short and to the point. 136.16. What is the ratio of the SF6 emissions (in thousand metric tons of CO2 equivalent) in 2000 in United States to that in Venezuela?
Offer a very short reply. 239.97. What is the ratio of the SF6 emissions (in thousand metric tons of CO2 equivalent) in 2005 in United States to that in Venezuela?
Provide a short and direct response. 186.37. What is the ratio of the SF6 emissions (in thousand metric tons of CO2 equivalent) in 2008 in United States to that in Venezuela?
Your answer should be compact. 161.46. What is the difference between the highest and the second highest SF6 emissions (in thousand metric tons of CO2 equivalent) of 1990?
Your response must be concise. 4.02e+04. What is the difference between the highest and the second highest SF6 emissions (in thousand metric tons of CO2 equivalent) of 2000?
Ensure brevity in your answer.  4.48e+04. What is the difference between the highest and the second highest SF6 emissions (in thousand metric tons of CO2 equivalent) in 2005?
Make the answer very short. 4.04e+04. What is the difference between the highest and the second highest SF6 emissions (in thousand metric tons of CO2 equivalent) in 2008?
Provide a short and direct response. 4.06e+04. What is the difference between the highest and the lowest SF6 emissions (in thousand metric tons of CO2 equivalent) of 1990?
Provide a succinct answer. 4.19e+04. What is the difference between the highest and the lowest SF6 emissions (in thousand metric tons of CO2 equivalent) in 2000?
Your answer should be very brief. 4.57e+04. What is the difference between the highest and the lowest SF6 emissions (in thousand metric tons of CO2 equivalent) in 2005?
Offer a very short reply. 4.17e+04. What is the difference between the highest and the lowest SF6 emissions (in thousand metric tons of CO2 equivalent) of 2008?
Give a very brief answer. 4.23e+04. 